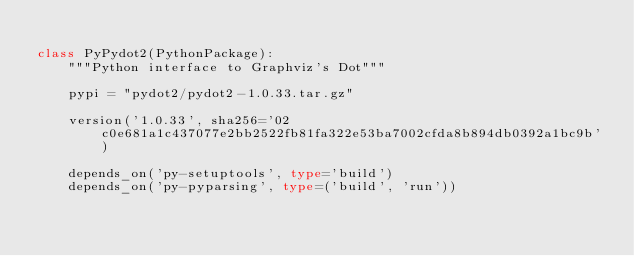<code> <loc_0><loc_0><loc_500><loc_500><_Python_>
class PyPydot2(PythonPackage):
    """Python interface to Graphviz's Dot"""

    pypi = "pydot2/pydot2-1.0.33.tar.gz"

    version('1.0.33', sha256='02c0e681a1c437077e2bb2522fb81fa322e53ba7002cfda8b894db0392a1bc9b')

    depends_on('py-setuptools', type='build')
    depends_on('py-pyparsing', type=('build', 'run'))
</code> 